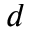<formula> <loc_0><loc_0><loc_500><loc_500>d</formula> 